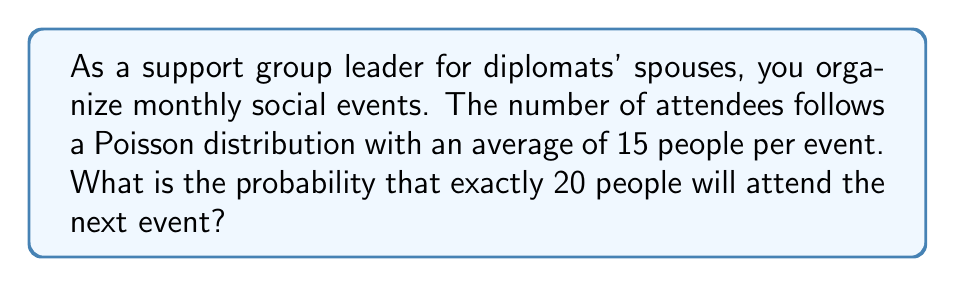Solve this math problem. To solve this problem, we'll use the Poisson distribution formula:

$$P(X = k) = \frac{e^{-\lambda} \lambda^k}{k!}$$

Where:
$\lambda$ = average number of events in the interval
$k$ = number of events we're calculating the probability for
$e$ = Euler's number (approximately 2.71828)

Given:
$\lambda = 15$ (average attendees per event)
$k = 20$ (number of attendees we're calculating the probability for)

Step 1: Plug the values into the formula
$$P(X = 20) = \frac{e^{-15} 15^{20}}{20!}$$

Step 2: Calculate $e^{-15}$
$e^{-15} \approx 3.059 \times 10^{-7}$

Step 3: Calculate $15^{20}$
$15^{20} \approx 3.269 \times 10^{23}$

Step 4: Calculate $20!$
$20! = 2.432902 \times 10^{18}$

Step 5: Put it all together
$$P(X = 20) = \frac{(3.059 \times 10^{-7})(3.269 \times 10^{23})}{2.432902 \times 10^{18}}$$

Step 6: Simplify
$$P(X = 20) \approx 0.0404$$

Therefore, the probability of exactly 20 people attending the next event is approximately 0.0404 or 4.04%.
Answer: 0.0404 (or 4.04%) 